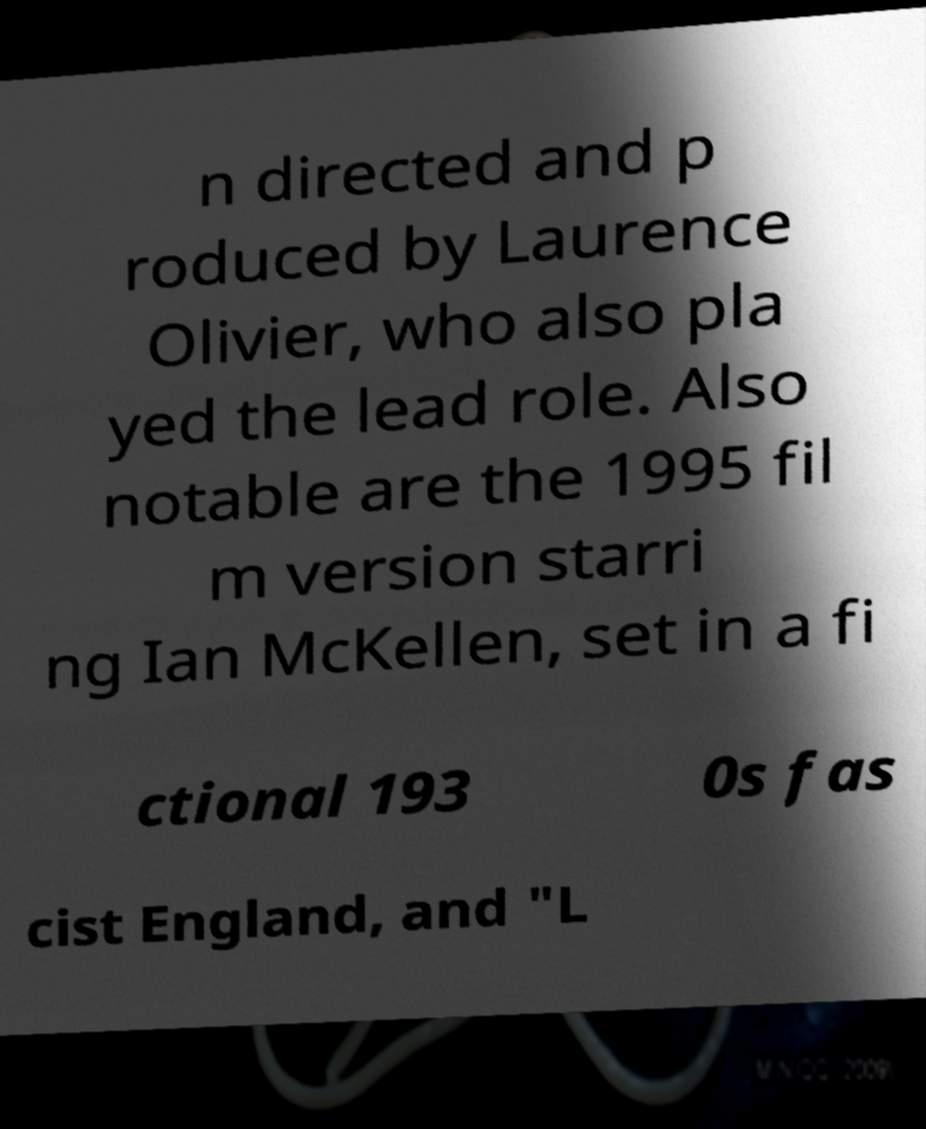Could you extract and type out the text from this image? n directed and p roduced by Laurence Olivier, who also pla yed the lead role. Also notable are the 1995 fil m version starri ng Ian McKellen, set in a fi ctional 193 0s fas cist England, and "L 